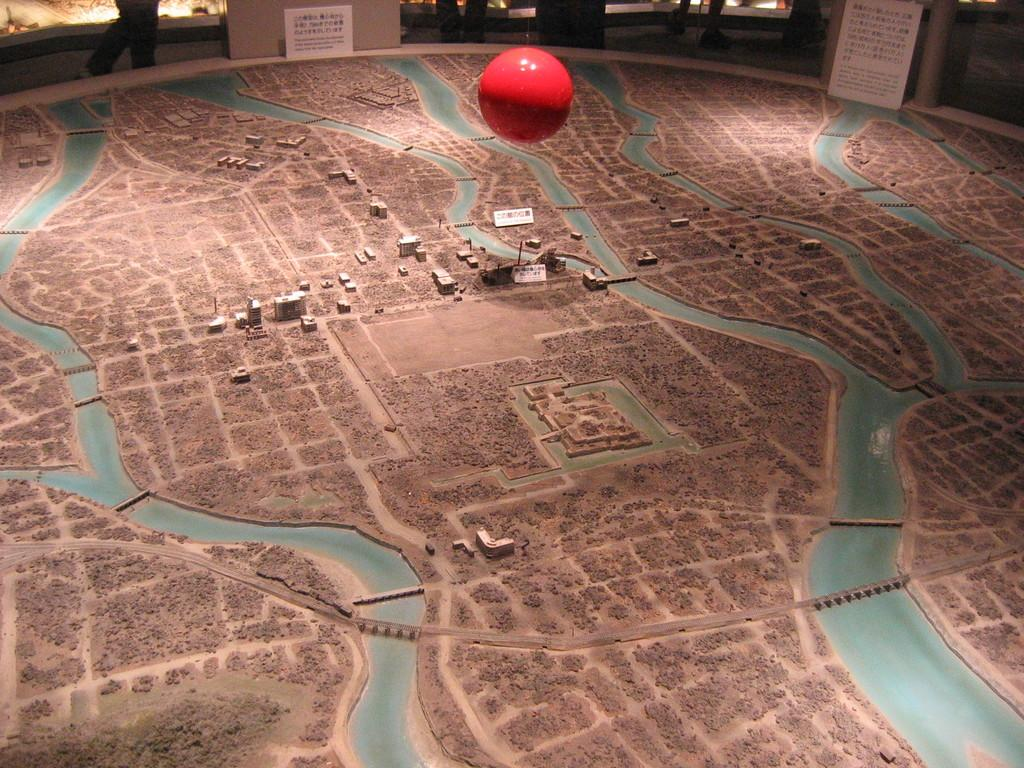What type of view is provided in the image? The image provides an aerial view. What structures can be seen from this perspective? There are buildings visible in the image. Are there any signs of human activity in the image? Yes, there are people in the background of the image. What additional object can be seen in the image? There is a red ball in the image. Where are the chairs located in the image? There are no chairs present in the image. What type of stream can be seen flowing through the buildings in the image? There is no stream visible in the image; it only shows buildings, people, and a red ball. 